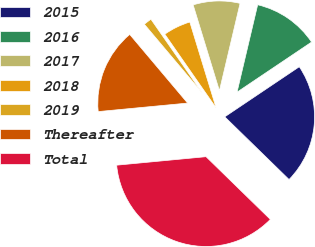<chart> <loc_0><loc_0><loc_500><loc_500><pie_chart><fcel>2015<fcel>2016<fcel>2017<fcel>2018<fcel>2019<fcel>Thereafter<fcel>Total<nl><fcel>21.72%<fcel>11.89%<fcel>8.42%<fcel>4.95%<fcel>1.47%<fcel>15.36%<fcel>36.19%<nl></chart> 